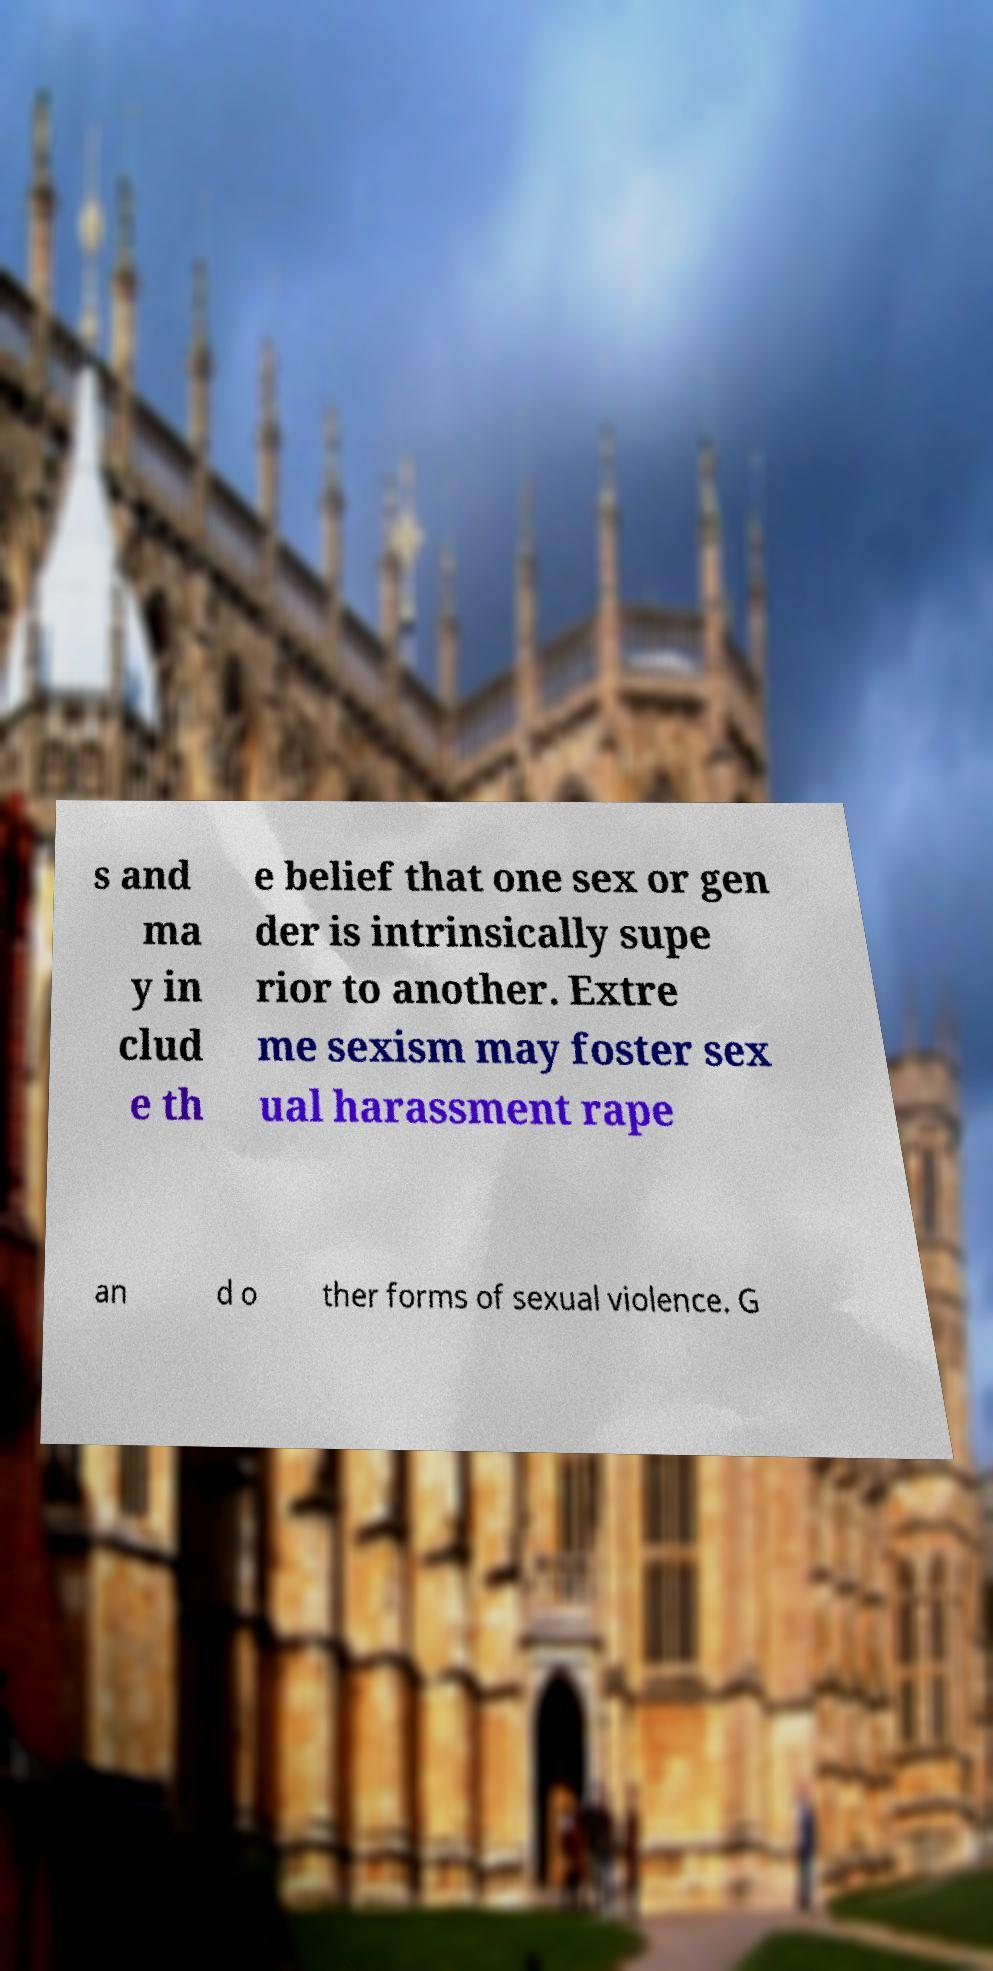Can you accurately transcribe the text from the provided image for me? s and ma y in clud e th e belief that one sex or gen der is intrinsically supe rior to another. Extre me sexism may foster sex ual harassment rape an d o ther forms of sexual violence. G 